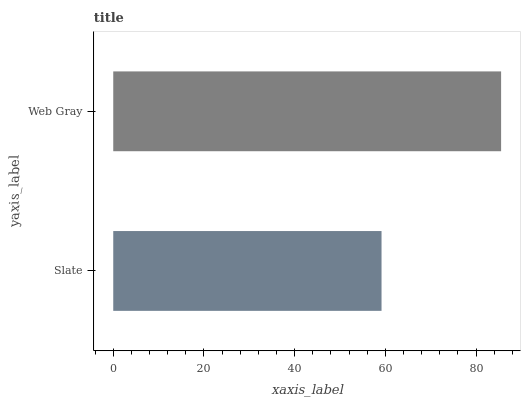Is Slate the minimum?
Answer yes or no. Yes. Is Web Gray the maximum?
Answer yes or no. Yes. Is Web Gray the minimum?
Answer yes or no. No. Is Web Gray greater than Slate?
Answer yes or no. Yes. Is Slate less than Web Gray?
Answer yes or no. Yes. Is Slate greater than Web Gray?
Answer yes or no. No. Is Web Gray less than Slate?
Answer yes or no. No. Is Web Gray the high median?
Answer yes or no. Yes. Is Slate the low median?
Answer yes or no. Yes. Is Slate the high median?
Answer yes or no. No. Is Web Gray the low median?
Answer yes or no. No. 